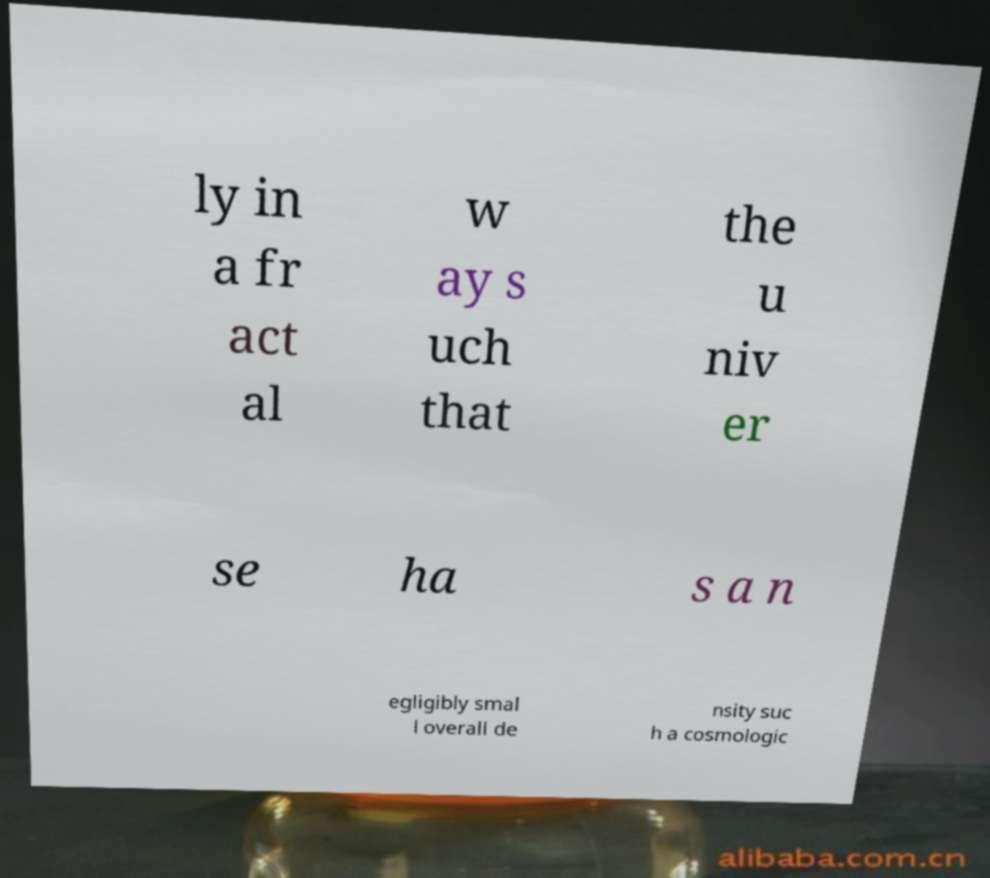Can you accurately transcribe the text from the provided image for me? ly in a fr act al w ay s uch that the u niv er se ha s a n egligibly smal l overall de nsity suc h a cosmologic 